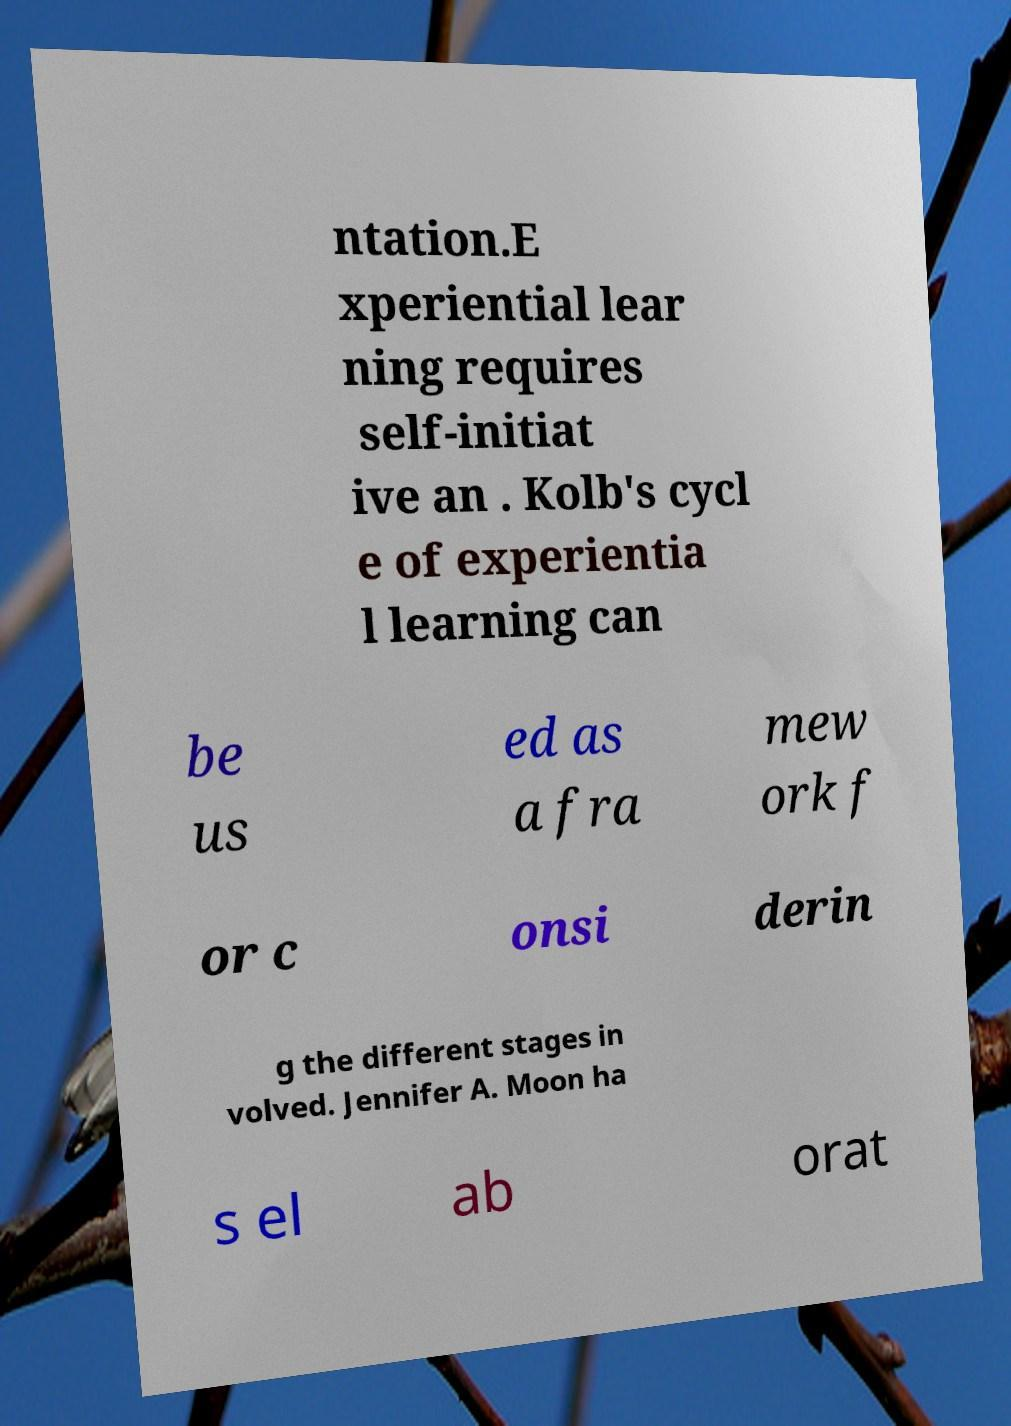Please read and relay the text visible in this image. What does it say? ntation.E xperiential lear ning requires self-initiat ive an . Kolb's cycl e of experientia l learning can be us ed as a fra mew ork f or c onsi derin g the different stages in volved. Jennifer A. Moon ha s el ab orat 